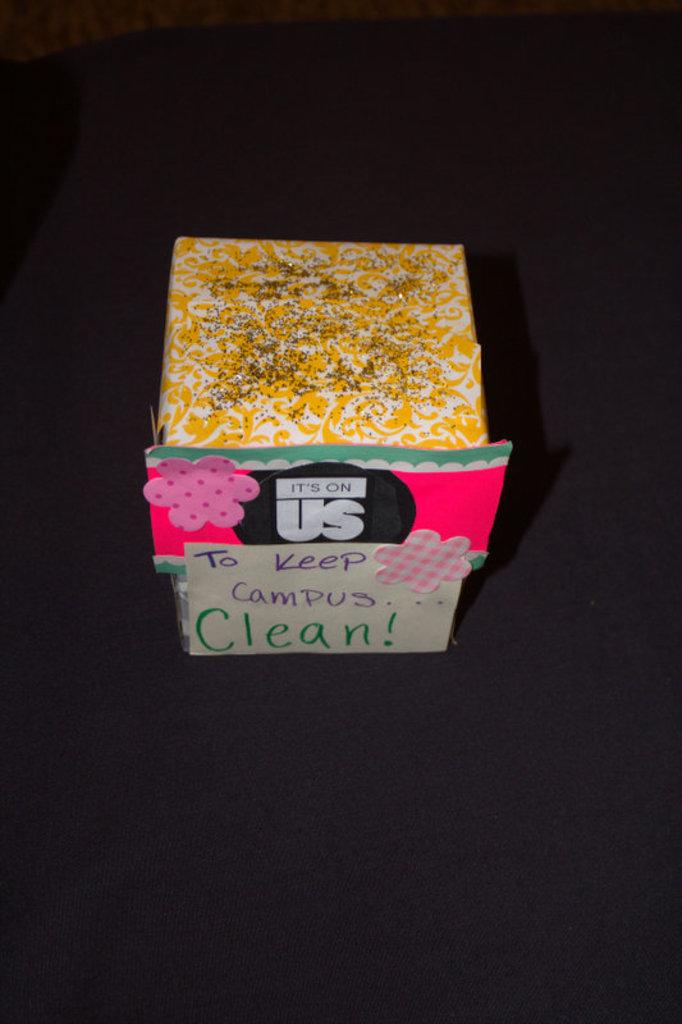What is to be kept clean?
Provide a short and direct response. Campus. What is the slogan at the top of the box?
Offer a very short reply. It's on us. 